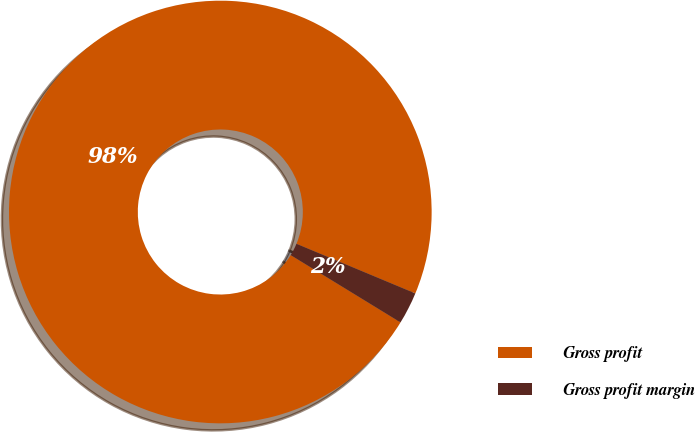Convert chart. <chart><loc_0><loc_0><loc_500><loc_500><pie_chart><fcel>Gross profit<fcel>Gross profit margin<nl><fcel>97.55%<fcel>2.45%<nl></chart> 